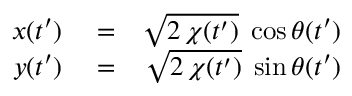Convert formula to latex. <formula><loc_0><loc_0><loc_500><loc_500>\begin{array} { r l r } { x ( t ^ { \prime } ) } & = } & { \sqrt { 2 \, \chi ( t ^ { \prime } ) } \, \cos \theta ( t ^ { \prime } ) } \\ { y ( t ^ { \prime } ) } & = } & { \sqrt { 2 \, \chi ( t ^ { \prime } ) } \, \sin \theta ( t ^ { \prime } ) } \end{array}</formula> 